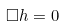<formula> <loc_0><loc_0><loc_500><loc_500>\square h = 0</formula> 